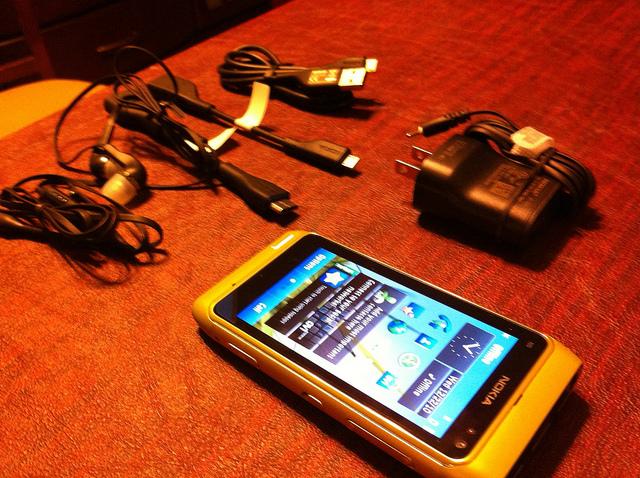Is the phone in a case?
Concise answer only. No. Is the phone turned on?
Write a very short answer. Yes. Does this object have scissors?
Concise answer only. No. What clips to the top?
Answer briefly. Charger. What device is laying on the table?
Short answer required. Phone. 